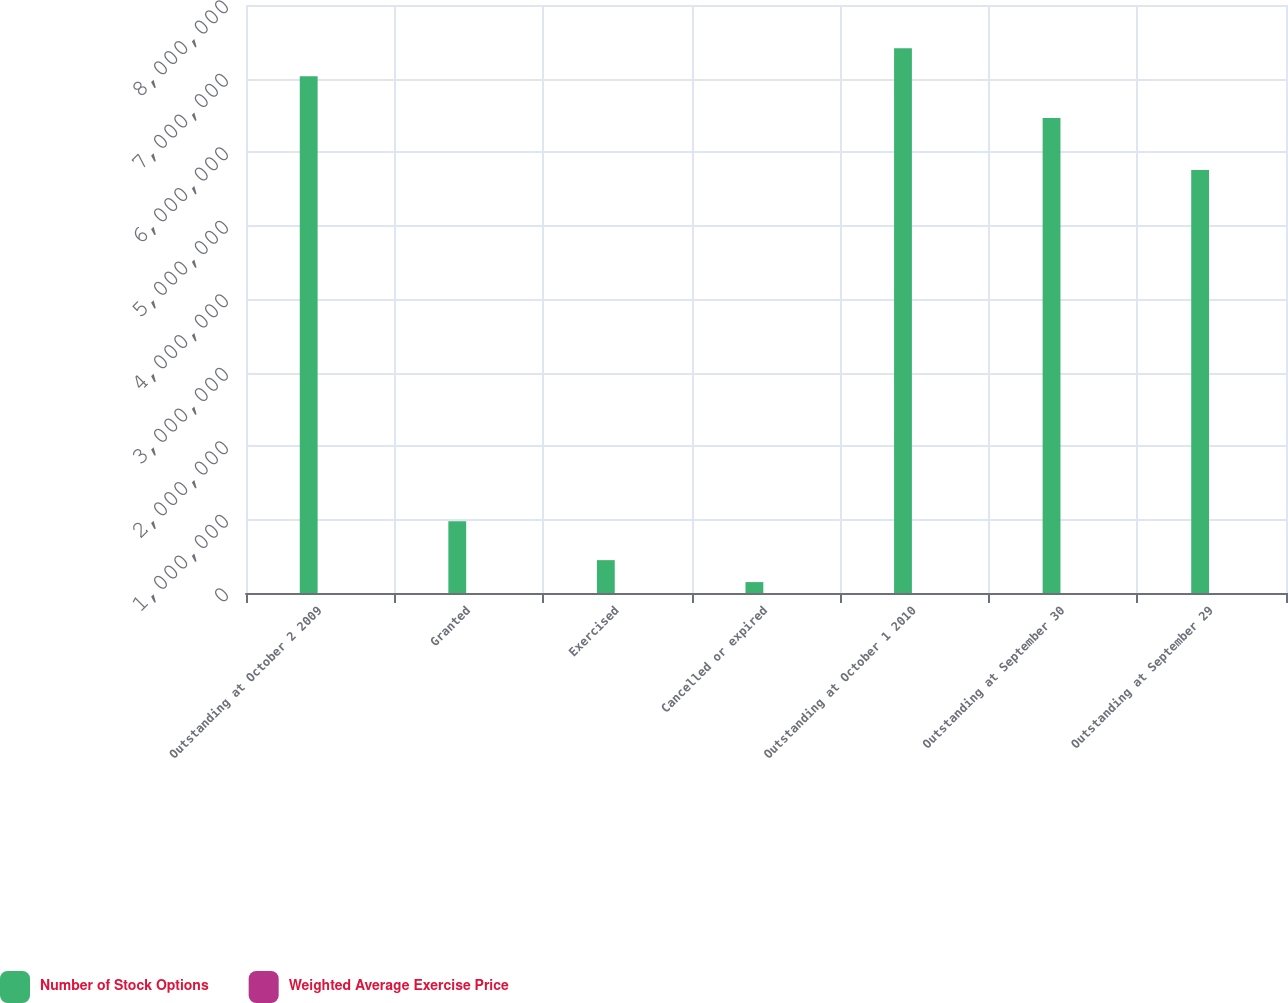Convert chart. <chart><loc_0><loc_0><loc_500><loc_500><stacked_bar_chart><ecel><fcel>Outstanding at October 2 2009<fcel>Granted<fcel>Exercised<fcel>Cancelled or expired<fcel>Outstanding at October 1 2010<fcel>Outstanding at September 30<fcel>Outstanding at September 29<nl><fcel>Number of Stock Options<fcel>7.03102e+06<fcel>975000<fcel>447200<fcel>148237<fcel>7.41058e+06<fcel>6.46151e+06<fcel>5.75673e+06<nl><fcel>Weighted Average Exercise Price<fcel>37.43<fcel>43.79<fcel>15.9<fcel>60.39<fcel>39.1<fcel>43.28<fcel>47.23<nl></chart> 